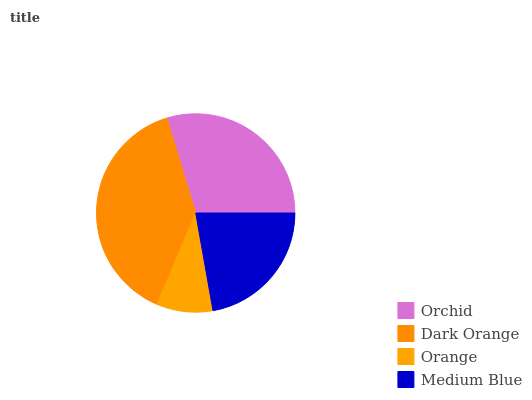Is Orange the minimum?
Answer yes or no. Yes. Is Dark Orange the maximum?
Answer yes or no. Yes. Is Dark Orange the minimum?
Answer yes or no. No. Is Orange the maximum?
Answer yes or no. No. Is Dark Orange greater than Orange?
Answer yes or no. Yes. Is Orange less than Dark Orange?
Answer yes or no. Yes. Is Orange greater than Dark Orange?
Answer yes or no. No. Is Dark Orange less than Orange?
Answer yes or no. No. Is Orchid the high median?
Answer yes or no. Yes. Is Medium Blue the low median?
Answer yes or no. Yes. Is Medium Blue the high median?
Answer yes or no. No. Is Dark Orange the low median?
Answer yes or no. No. 